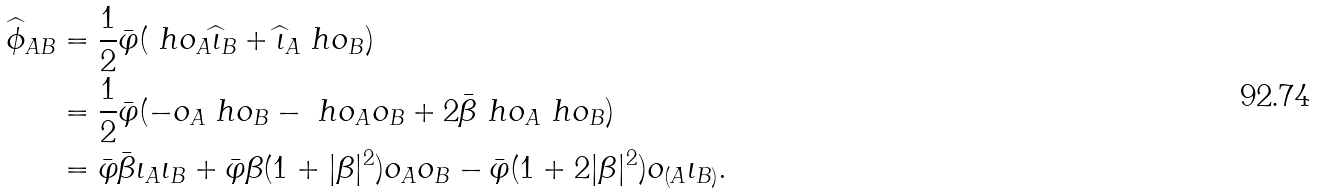<formula> <loc_0><loc_0><loc_500><loc_500>\widehat { \phi } _ { A B } & = \frac { 1 } { 2 } \bar { \varphi } ( \ h o _ { A } \widehat { \iota } _ { B } + \widehat { \iota } _ { A } \ h o _ { B } ) \\ & = \frac { 1 } { 2 } \bar { \varphi } ( - o _ { A } \ h o _ { B } - \ h o _ { A } o _ { B } + 2 \bar { \beta } \ h o _ { A } \ h o _ { B } ) \\ & = \bar { \varphi } \bar { \beta } \iota _ { A } \iota _ { B } + \bar { \varphi } \beta ( 1 + | \beta | ^ { 2 } ) o _ { A } o _ { B } - \bar { \varphi } ( 1 + 2 | \beta | ^ { 2 } ) o _ { ( A } \iota _ { B ) } .</formula> 